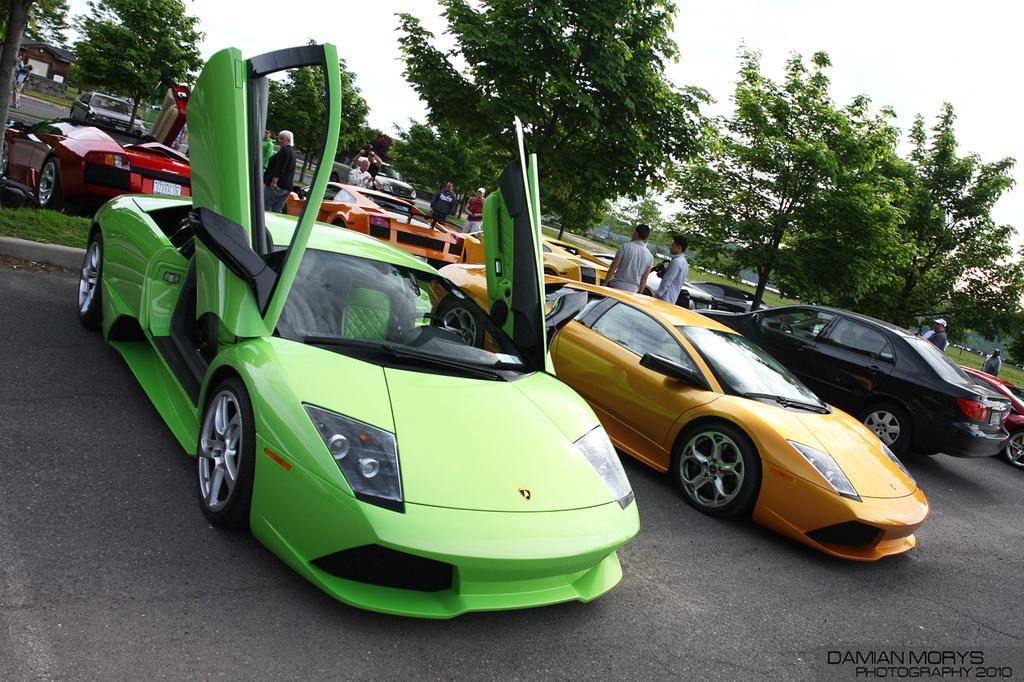Please provide a concise description of this image. In this image I can see there are lot of cars are parked on the road. In the middle few people are standing and there are trees, at the top it is the sky. In the right hand side bottom there is the name. 